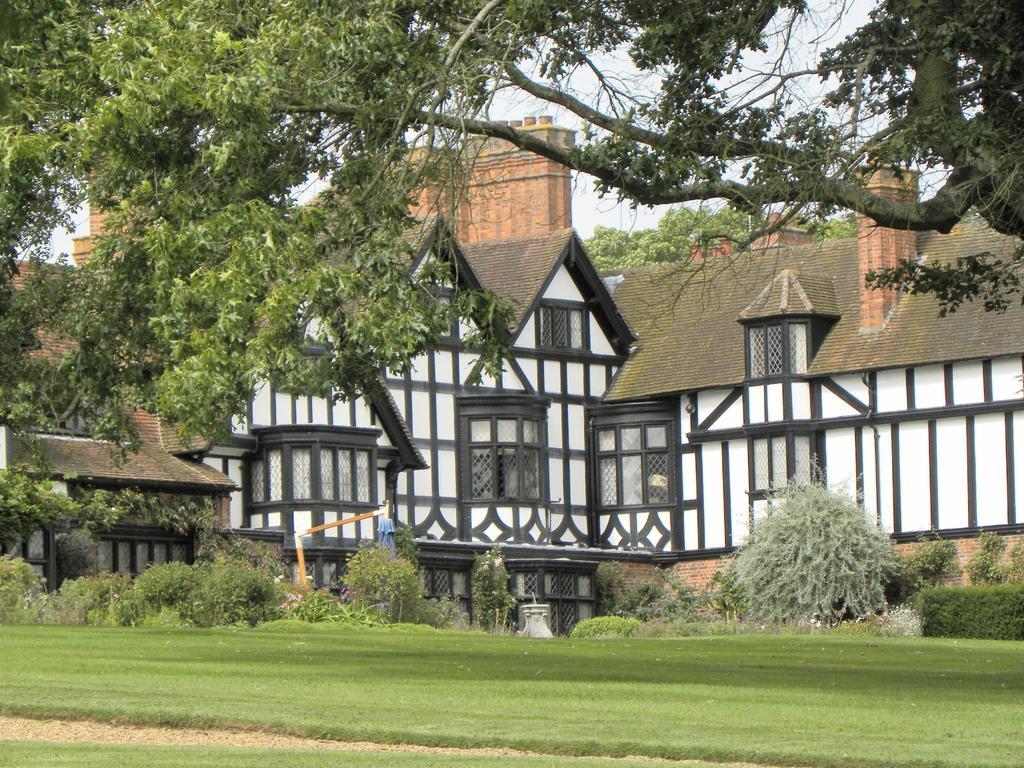Please provide a concise description of this image. In this image we can see the buildings, in front of the buildings we can see there are trees, grass and rods. In the background, we can see the sky. 